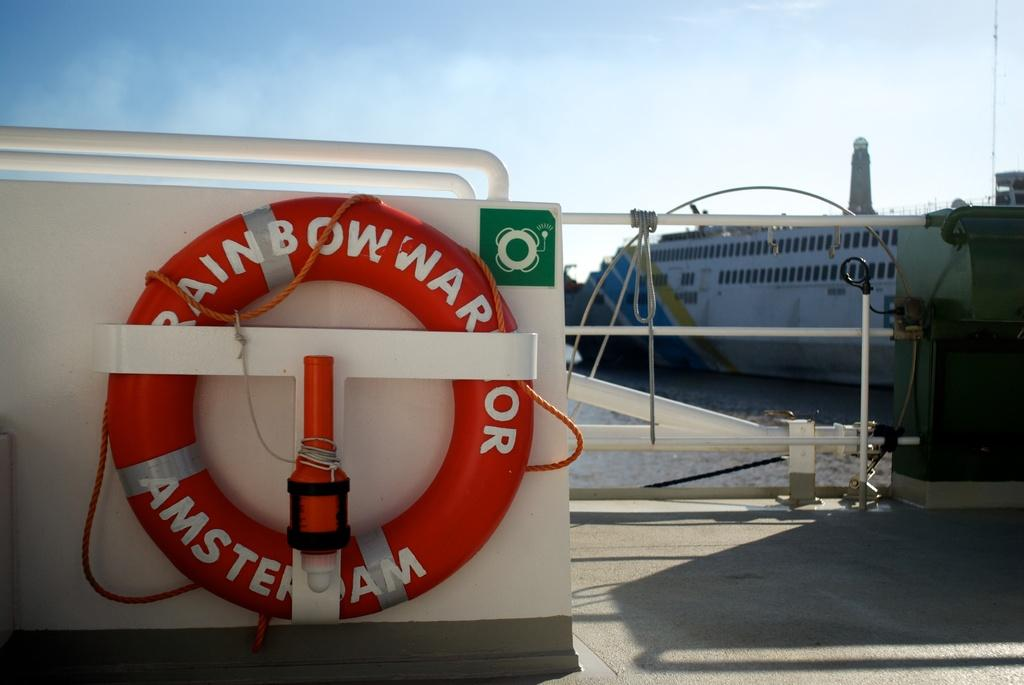<image>
Summarize the visual content of the image. A round red life preserver from the Rainbow Warrior Amsterdam 